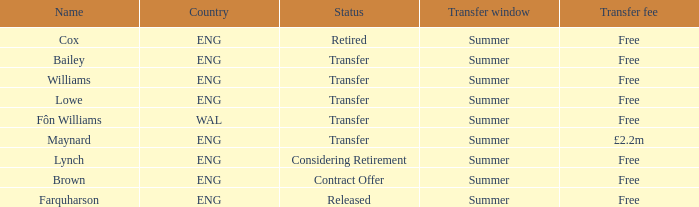Would you mind parsing the complete table? {'header': ['Name', 'Country', 'Status', 'Transfer window', 'Transfer fee'], 'rows': [['Cox', 'ENG', 'Retired', 'Summer', 'Free'], ['Bailey', 'ENG', 'Transfer', 'Summer', 'Free'], ['Williams', 'ENG', 'Transfer', 'Summer', 'Free'], ['Lowe', 'ENG', 'Transfer', 'Summer', 'Free'], ['Fôn Williams', 'WAL', 'Transfer', 'Summer', 'Free'], ['Maynard', 'ENG', 'Transfer', 'Summer', '£2.2m'], ['Lynch', 'ENG', 'Considering Retirement', 'Summer', 'Free'], ['Brown', 'ENG', 'Contract Offer', 'Summer', 'Free'], ['Farquharson', 'ENG', 'Released', 'Summer', 'Free']]} What is the transfer period with a status of transfer from the wal nation? Summer. 